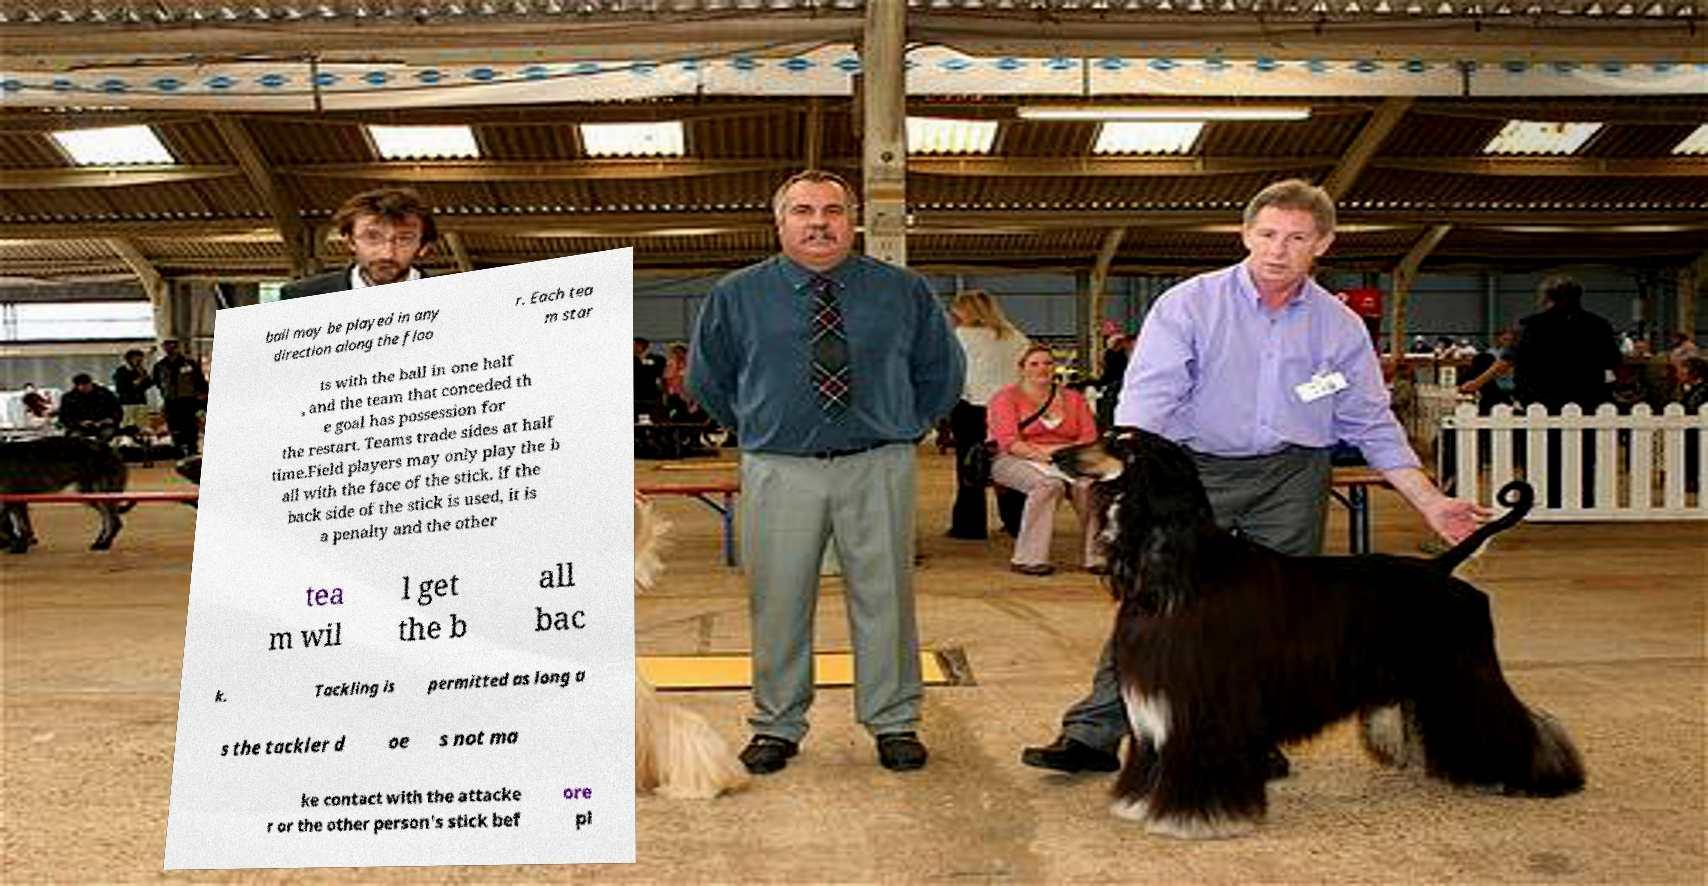Please read and relay the text visible in this image. What does it say? ball may be played in any direction along the floo r. Each tea m star ts with the ball in one half , and the team that conceded th e goal has possession for the restart. Teams trade sides at half time.Field players may only play the b all with the face of the stick. If the back side of the stick is used, it is a penalty and the other tea m wil l get the b all bac k. Tackling is permitted as long a s the tackler d oe s not ma ke contact with the attacke r or the other person's stick bef ore pl 